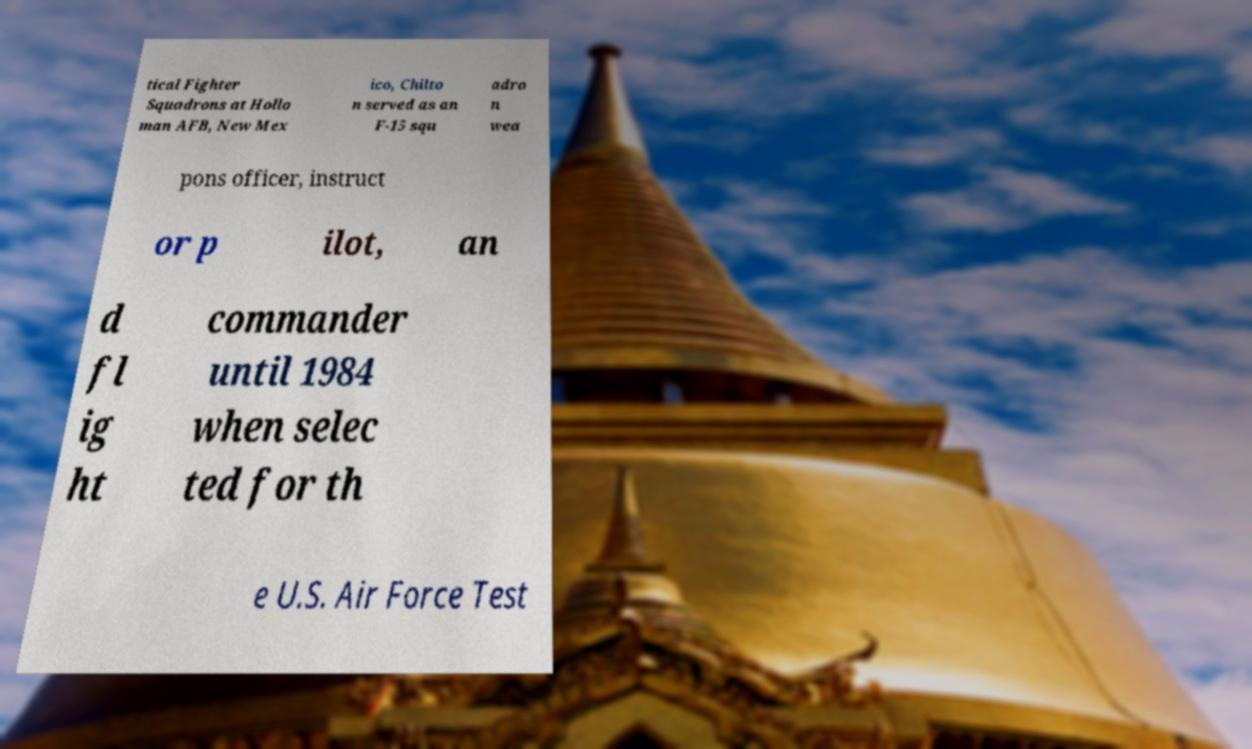What messages or text are displayed in this image? I need them in a readable, typed format. tical Fighter Squadrons at Hollo man AFB, New Mex ico, Chilto n served as an F-15 squ adro n wea pons officer, instruct or p ilot, an d fl ig ht commander until 1984 when selec ted for th e U.S. Air Force Test 